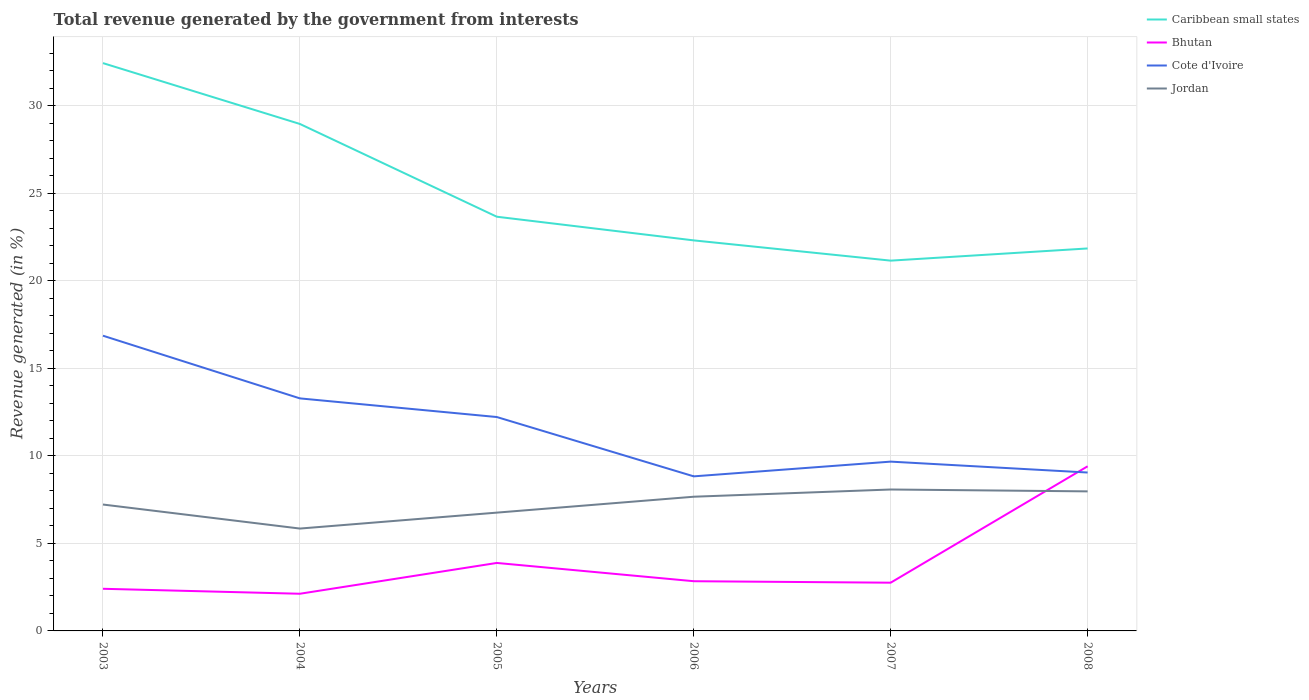Does the line corresponding to Cote d'Ivoire intersect with the line corresponding to Jordan?
Your answer should be very brief. No. Is the number of lines equal to the number of legend labels?
Your answer should be compact. Yes. Across all years, what is the maximum total revenue generated in Cote d'Ivoire?
Provide a short and direct response. 8.83. What is the total total revenue generated in Bhutan in the graph?
Your response must be concise. -0.72. What is the difference between the highest and the second highest total revenue generated in Bhutan?
Your answer should be very brief. 7.28. What is the difference between the highest and the lowest total revenue generated in Caribbean small states?
Give a very brief answer. 2. How many years are there in the graph?
Keep it short and to the point. 6. Does the graph contain grids?
Offer a very short reply. Yes. How are the legend labels stacked?
Provide a succinct answer. Vertical. What is the title of the graph?
Provide a short and direct response. Total revenue generated by the government from interests. What is the label or title of the X-axis?
Make the answer very short. Years. What is the label or title of the Y-axis?
Provide a succinct answer. Revenue generated (in %). What is the Revenue generated (in %) of Caribbean small states in 2003?
Provide a succinct answer. 32.44. What is the Revenue generated (in %) of Bhutan in 2003?
Ensure brevity in your answer.  2.41. What is the Revenue generated (in %) in Cote d'Ivoire in 2003?
Keep it short and to the point. 16.87. What is the Revenue generated (in %) of Jordan in 2003?
Provide a succinct answer. 7.22. What is the Revenue generated (in %) in Caribbean small states in 2004?
Provide a succinct answer. 28.97. What is the Revenue generated (in %) in Bhutan in 2004?
Offer a very short reply. 2.12. What is the Revenue generated (in %) of Cote d'Ivoire in 2004?
Make the answer very short. 13.29. What is the Revenue generated (in %) in Jordan in 2004?
Keep it short and to the point. 5.85. What is the Revenue generated (in %) in Caribbean small states in 2005?
Provide a short and direct response. 23.67. What is the Revenue generated (in %) of Bhutan in 2005?
Offer a terse response. 3.88. What is the Revenue generated (in %) of Cote d'Ivoire in 2005?
Make the answer very short. 12.22. What is the Revenue generated (in %) of Jordan in 2005?
Offer a terse response. 6.76. What is the Revenue generated (in %) of Caribbean small states in 2006?
Keep it short and to the point. 22.31. What is the Revenue generated (in %) in Bhutan in 2006?
Provide a succinct answer. 2.84. What is the Revenue generated (in %) in Cote d'Ivoire in 2006?
Offer a terse response. 8.83. What is the Revenue generated (in %) in Jordan in 2006?
Give a very brief answer. 7.67. What is the Revenue generated (in %) in Caribbean small states in 2007?
Your response must be concise. 21.16. What is the Revenue generated (in %) in Bhutan in 2007?
Your response must be concise. 2.76. What is the Revenue generated (in %) in Cote d'Ivoire in 2007?
Your answer should be compact. 9.67. What is the Revenue generated (in %) of Jordan in 2007?
Ensure brevity in your answer.  8.08. What is the Revenue generated (in %) of Caribbean small states in 2008?
Offer a very short reply. 21.85. What is the Revenue generated (in %) of Bhutan in 2008?
Your response must be concise. 9.41. What is the Revenue generated (in %) in Cote d'Ivoire in 2008?
Your answer should be compact. 9.05. What is the Revenue generated (in %) in Jordan in 2008?
Provide a succinct answer. 7.97. Across all years, what is the maximum Revenue generated (in %) in Caribbean small states?
Your response must be concise. 32.44. Across all years, what is the maximum Revenue generated (in %) in Bhutan?
Offer a terse response. 9.41. Across all years, what is the maximum Revenue generated (in %) of Cote d'Ivoire?
Offer a very short reply. 16.87. Across all years, what is the maximum Revenue generated (in %) of Jordan?
Keep it short and to the point. 8.08. Across all years, what is the minimum Revenue generated (in %) of Caribbean small states?
Ensure brevity in your answer.  21.16. Across all years, what is the minimum Revenue generated (in %) in Bhutan?
Offer a very short reply. 2.12. Across all years, what is the minimum Revenue generated (in %) in Cote d'Ivoire?
Give a very brief answer. 8.83. Across all years, what is the minimum Revenue generated (in %) in Jordan?
Your answer should be compact. 5.85. What is the total Revenue generated (in %) in Caribbean small states in the graph?
Your answer should be very brief. 150.4. What is the total Revenue generated (in %) of Bhutan in the graph?
Your answer should be compact. 23.42. What is the total Revenue generated (in %) of Cote d'Ivoire in the graph?
Offer a very short reply. 69.93. What is the total Revenue generated (in %) of Jordan in the graph?
Offer a very short reply. 43.55. What is the difference between the Revenue generated (in %) of Caribbean small states in 2003 and that in 2004?
Provide a succinct answer. 3.48. What is the difference between the Revenue generated (in %) of Bhutan in 2003 and that in 2004?
Give a very brief answer. 0.28. What is the difference between the Revenue generated (in %) of Cote d'Ivoire in 2003 and that in 2004?
Your answer should be very brief. 3.58. What is the difference between the Revenue generated (in %) of Jordan in 2003 and that in 2004?
Ensure brevity in your answer.  1.37. What is the difference between the Revenue generated (in %) of Caribbean small states in 2003 and that in 2005?
Your answer should be very brief. 8.78. What is the difference between the Revenue generated (in %) in Bhutan in 2003 and that in 2005?
Offer a terse response. -1.48. What is the difference between the Revenue generated (in %) in Cote d'Ivoire in 2003 and that in 2005?
Offer a very short reply. 4.65. What is the difference between the Revenue generated (in %) in Jordan in 2003 and that in 2005?
Make the answer very short. 0.46. What is the difference between the Revenue generated (in %) in Caribbean small states in 2003 and that in 2006?
Keep it short and to the point. 10.13. What is the difference between the Revenue generated (in %) of Bhutan in 2003 and that in 2006?
Your response must be concise. -0.43. What is the difference between the Revenue generated (in %) in Cote d'Ivoire in 2003 and that in 2006?
Make the answer very short. 8.04. What is the difference between the Revenue generated (in %) in Jordan in 2003 and that in 2006?
Make the answer very short. -0.45. What is the difference between the Revenue generated (in %) of Caribbean small states in 2003 and that in 2007?
Ensure brevity in your answer.  11.29. What is the difference between the Revenue generated (in %) of Bhutan in 2003 and that in 2007?
Keep it short and to the point. -0.35. What is the difference between the Revenue generated (in %) in Cote d'Ivoire in 2003 and that in 2007?
Offer a very short reply. 7.19. What is the difference between the Revenue generated (in %) of Jordan in 2003 and that in 2007?
Your answer should be very brief. -0.86. What is the difference between the Revenue generated (in %) of Caribbean small states in 2003 and that in 2008?
Make the answer very short. 10.59. What is the difference between the Revenue generated (in %) of Bhutan in 2003 and that in 2008?
Your answer should be compact. -7. What is the difference between the Revenue generated (in %) in Cote d'Ivoire in 2003 and that in 2008?
Give a very brief answer. 7.82. What is the difference between the Revenue generated (in %) of Jordan in 2003 and that in 2008?
Make the answer very short. -0.75. What is the difference between the Revenue generated (in %) of Caribbean small states in 2004 and that in 2005?
Ensure brevity in your answer.  5.3. What is the difference between the Revenue generated (in %) of Bhutan in 2004 and that in 2005?
Your answer should be compact. -1.76. What is the difference between the Revenue generated (in %) of Cote d'Ivoire in 2004 and that in 2005?
Your answer should be very brief. 1.07. What is the difference between the Revenue generated (in %) in Jordan in 2004 and that in 2005?
Your response must be concise. -0.91. What is the difference between the Revenue generated (in %) in Caribbean small states in 2004 and that in 2006?
Offer a terse response. 6.65. What is the difference between the Revenue generated (in %) of Bhutan in 2004 and that in 2006?
Offer a terse response. -0.72. What is the difference between the Revenue generated (in %) of Cote d'Ivoire in 2004 and that in 2006?
Ensure brevity in your answer.  4.45. What is the difference between the Revenue generated (in %) in Jordan in 2004 and that in 2006?
Offer a very short reply. -1.82. What is the difference between the Revenue generated (in %) in Caribbean small states in 2004 and that in 2007?
Your answer should be very brief. 7.81. What is the difference between the Revenue generated (in %) of Bhutan in 2004 and that in 2007?
Your answer should be compact. -0.63. What is the difference between the Revenue generated (in %) of Cote d'Ivoire in 2004 and that in 2007?
Provide a short and direct response. 3.61. What is the difference between the Revenue generated (in %) of Jordan in 2004 and that in 2007?
Provide a succinct answer. -2.23. What is the difference between the Revenue generated (in %) in Caribbean small states in 2004 and that in 2008?
Give a very brief answer. 7.11. What is the difference between the Revenue generated (in %) of Bhutan in 2004 and that in 2008?
Your response must be concise. -7.28. What is the difference between the Revenue generated (in %) of Cote d'Ivoire in 2004 and that in 2008?
Ensure brevity in your answer.  4.24. What is the difference between the Revenue generated (in %) of Jordan in 2004 and that in 2008?
Give a very brief answer. -2.12. What is the difference between the Revenue generated (in %) in Caribbean small states in 2005 and that in 2006?
Provide a succinct answer. 1.35. What is the difference between the Revenue generated (in %) in Bhutan in 2005 and that in 2006?
Your answer should be very brief. 1.04. What is the difference between the Revenue generated (in %) of Cote d'Ivoire in 2005 and that in 2006?
Offer a very short reply. 3.39. What is the difference between the Revenue generated (in %) of Jordan in 2005 and that in 2006?
Make the answer very short. -0.91. What is the difference between the Revenue generated (in %) of Caribbean small states in 2005 and that in 2007?
Offer a very short reply. 2.51. What is the difference between the Revenue generated (in %) of Bhutan in 2005 and that in 2007?
Ensure brevity in your answer.  1.13. What is the difference between the Revenue generated (in %) in Cote d'Ivoire in 2005 and that in 2007?
Make the answer very short. 2.55. What is the difference between the Revenue generated (in %) of Jordan in 2005 and that in 2007?
Provide a short and direct response. -1.32. What is the difference between the Revenue generated (in %) of Caribbean small states in 2005 and that in 2008?
Ensure brevity in your answer.  1.81. What is the difference between the Revenue generated (in %) in Bhutan in 2005 and that in 2008?
Your answer should be compact. -5.52. What is the difference between the Revenue generated (in %) of Cote d'Ivoire in 2005 and that in 2008?
Provide a short and direct response. 3.17. What is the difference between the Revenue generated (in %) of Jordan in 2005 and that in 2008?
Give a very brief answer. -1.21. What is the difference between the Revenue generated (in %) of Caribbean small states in 2006 and that in 2007?
Offer a very short reply. 1.16. What is the difference between the Revenue generated (in %) in Bhutan in 2006 and that in 2007?
Your answer should be very brief. 0.08. What is the difference between the Revenue generated (in %) in Cote d'Ivoire in 2006 and that in 2007?
Offer a very short reply. -0.84. What is the difference between the Revenue generated (in %) of Jordan in 2006 and that in 2007?
Ensure brevity in your answer.  -0.41. What is the difference between the Revenue generated (in %) of Caribbean small states in 2006 and that in 2008?
Your answer should be compact. 0.46. What is the difference between the Revenue generated (in %) in Bhutan in 2006 and that in 2008?
Offer a very short reply. -6.57. What is the difference between the Revenue generated (in %) of Cote d'Ivoire in 2006 and that in 2008?
Ensure brevity in your answer.  -0.22. What is the difference between the Revenue generated (in %) of Jordan in 2006 and that in 2008?
Your answer should be compact. -0.31. What is the difference between the Revenue generated (in %) in Caribbean small states in 2007 and that in 2008?
Ensure brevity in your answer.  -0.7. What is the difference between the Revenue generated (in %) in Bhutan in 2007 and that in 2008?
Provide a short and direct response. -6.65. What is the difference between the Revenue generated (in %) in Cote d'Ivoire in 2007 and that in 2008?
Your response must be concise. 0.62. What is the difference between the Revenue generated (in %) in Jordan in 2007 and that in 2008?
Give a very brief answer. 0.11. What is the difference between the Revenue generated (in %) of Caribbean small states in 2003 and the Revenue generated (in %) of Bhutan in 2004?
Your answer should be very brief. 30.32. What is the difference between the Revenue generated (in %) in Caribbean small states in 2003 and the Revenue generated (in %) in Cote d'Ivoire in 2004?
Your answer should be compact. 19.16. What is the difference between the Revenue generated (in %) of Caribbean small states in 2003 and the Revenue generated (in %) of Jordan in 2004?
Your answer should be very brief. 26.59. What is the difference between the Revenue generated (in %) of Bhutan in 2003 and the Revenue generated (in %) of Cote d'Ivoire in 2004?
Your response must be concise. -10.88. What is the difference between the Revenue generated (in %) of Bhutan in 2003 and the Revenue generated (in %) of Jordan in 2004?
Provide a short and direct response. -3.44. What is the difference between the Revenue generated (in %) in Cote d'Ivoire in 2003 and the Revenue generated (in %) in Jordan in 2004?
Your answer should be compact. 11.02. What is the difference between the Revenue generated (in %) of Caribbean small states in 2003 and the Revenue generated (in %) of Bhutan in 2005?
Your response must be concise. 28.56. What is the difference between the Revenue generated (in %) of Caribbean small states in 2003 and the Revenue generated (in %) of Cote d'Ivoire in 2005?
Make the answer very short. 20.22. What is the difference between the Revenue generated (in %) in Caribbean small states in 2003 and the Revenue generated (in %) in Jordan in 2005?
Give a very brief answer. 25.68. What is the difference between the Revenue generated (in %) of Bhutan in 2003 and the Revenue generated (in %) of Cote d'Ivoire in 2005?
Your response must be concise. -9.81. What is the difference between the Revenue generated (in %) in Bhutan in 2003 and the Revenue generated (in %) in Jordan in 2005?
Make the answer very short. -4.35. What is the difference between the Revenue generated (in %) of Cote d'Ivoire in 2003 and the Revenue generated (in %) of Jordan in 2005?
Ensure brevity in your answer.  10.11. What is the difference between the Revenue generated (in %) of Caribbean small states in 2003 and the Revenue generated (in %) of Bhutan in 2006?
Give a very brief answer. 29.6. What is the difference between the Revenue generated (in %) in Caribbean small states in 2003 and the Revenue generated (in %) in Cote d'Ivoire in 2006?
Keep it short and to the point. 23.61. What is the difference between the Revenue generated (in %) of Caribbean small states in 2003 and the Revenue generated (in %) of Jordan in 2006?
Your answer should be very brief. 24.77. What is the difference between the Revenue generated (in %) of Bhutan in 2003 and the Revenue generated (in %) of Cote d'Ivoire in 2006?
Offer a terse response. -6.42. What is the difference between the Revenue generated (in %) of Bhutan in 2003 and the Revenue generated (in %) of Jordan in 2006?
Offer a terse response. -5.26. What is the difference between the Revenue generated (in %) in Cote d'Ivoire in 2003 and the Revenue generated (in %) in Jordan in 2006?
Make the answer very short. 9.2. What is the difference between the Revenue generated (in %) of Caribbean small states in 2003 and the Revenue generated (in %) of Bhutan in 2007?
Your answer should be very brief. 29.69. What is the difference between the Revenue generated (in %) in Caribbean small states in 2003 and the Revenue generated (in %) in Cote d'Ivoire in 2007?
Provide a short and direct response. 22.77. What is the difference between the Revenue generated (in %) in Caribbean small states in 2003 and the Revenue generated (in %) in Jordan in 2007?
Ensure brevity in your answer.  24.36. What is the difference between the Revenue generated (in %) of Bhutan in 2003 and the Revenue generated (in %) of Cote d'Ivoire in 2007?
Make the answer very short. -7.27. What is the difference between the Revenue generated (in %) in Bhutan in 2003 and the Revenue generated (in %) in Jordan in 2007?
Keep it short and to the point. -5.67. What is the difference between the Revenue generated (in %) in Cote d'Ivoire in 2003 and the Revenue generated (in %) in Jordan in 2007?
Provide a succinct answer. 8.79. What is the difference between the Revenue generated (in %) in Caribbean small states in 2003 and the Revenue generated (in %) in Bhutan in 2008?
Make the answer very short. 23.04. What is the difference between the Revenue generated (in %) of Caribbean small states in 2003 and the Revenue generated (in %) of Cote d'Ivoire in 2008?
Provide a short and direct response. 23.39. What is the difference between the Revenue generated (in %) in Caribbean small states in 2003 and the Revenue generated (in %) in Jordan in 2008?
Keep it short and to the point. 24.47. What is the difference between the Revenue generated (in %) in Bhutan in 2003 and the Revenue generated (in %) in Cote d'Ivoire in 2008?
Keep it short and to the point. -6.64. What is the difference between the Revenue generated (in %) in Bhutan in 2003 and the Revenue generated (in %) in Jordan in 2008?
Make the answer very short. -5.57. What is the difference between the Revenue generated (in %) of Cote d'Ivoire in 2003 and the Revenue generated (in %) of Jordan in 2008?
Provide a succinct answer. 8.89. What is the difference between the Revenue generated (in %) in Caribbean small states in 2004 and the Revenue generated (in %) in Bhutan in 2005?
Your answer should be compact. 25.08. What is the difference between the Revenue generated (in %) in Caribbean small states in 2004 and the Revenue generated (in %) in Cote d'Ivoire in 2005?
Provide a short and direct response. 16.75. What is the difference between the Revenue generated (in %) of Caribbean small states in 2004 and the Revenue generated (in %) of Jordan in 2005?
Provide a succinct answer. 22.21. What is the difference between the Revenue generated (in %) in Bhutan in 2004 and the Revenue generated (in %) in Cote d'Ivoire in 2005?
Offer a very short reply. -10.1. What is the difference between the Revenue generated (in %) in Bhutan in 2004 and the Revenue generated (in %) in Jordan in 2005?
Keep it short and to the point. -4.64. What is the difference between the Revenue generated (in %) of Cote d'Ivoire in 2004 and the Revenue generated (in %) of Jordan in 2005?
Offer a terse response. 6.53. What is the difference between the Revenue generated (in %) in Caribbean small states in 2004 and the Revenue generated (in %) in Bhutan in 2006?
Provide a succinct answer. 26.13. What is the difference between the Revenue generated (in %) in Caribbean small states in 2004 and the Revenue generated (in %) in Cote d'Ivoire in 2006?
Ensure brevity in your answer.  20.13. What is the difference between the Revenue generated (in %) of Caribbean small states in 2004 and the Revenue generated (in %) of Jordan in 2006?
Your answer should be compact. 21.3. What is the difference between the Revenue generated (in %) of Bhutan in 2004 and the Revenue generated (in %) of Cote d'Ivoire in 2006?
Ensure brevity in your answer.  -6.71. What is the difference between the Revenue generated (in %) of Bhutan in 2004 and the Revenue generated (in %) of Jordan in 2006?
Provide a short and direct response. -5.54. What is the difference between the Revenue generated (in %) in Cote d'Ivoire in 2004 and the Revenue generated (in %) in Jordan in 2006?
Your answer should be very brief. 5.62. What is the difference between the Revenue generated (in %) in Caribbean small states in 2004 and the Revenue generated (in %) in Bhutan in 2007?
Ensure brevity in your answer.  26.21. What is the difference between the Revenue generated (in %) in Caribbean small states in 2004 and the Revenue generated (in %) in Cote d'Ivoire in 2007?
Offer a very short reply. 19.29. What is the difference between the Revenue generated (in %) of Caribbean small states in 2004 and the Revenue generated (in %) of Jordan in 2007?
Offer a very short reply. 20.89. What is the difference between the Revenue generated (in %) of Bhutan in 2004 and the Revenue generated (in %) of Cote d'Ivoire in 2007?
Offer a terse response. -7.55. What is the difference between the Revenue generated (in %) in Bhutan in 2004 and the Revenue generated (in %) in Jordan in 2007?
Provide a short and direct response. -5.96. What is the difference between the Revenue generated (in %) in Cote d'Ivoire in 2004 and the Revenue generated (in %) in Jordan in 2007?
Your answer should be very brief. 5.21. What is the difference between the Revenue generated (in %) in Caribbean small states in 2004 and the Revenue generated (in %) in Bhutan in 2008?
Offer a very short reply. 19.56. What is the difference between the Revenue generated (in %) in Caribbean small states in 2004 and the Revenue generated (in %) in Cote d'Ivoire in 2008?
Offer a very short reply. 19.92. What is the difference between the Revenue generated (in %) of Caribbean small states in 2004 and the Revenue generated (in %) of Jordan in 2008?
Your answer should be very brief. 20.99. What is the difference between the Revenue generated (in %) of Bhutan in 2004 and the Revenue generated (in %) of Cote d'Ivoire in 2008?
Keep it short and to the point. -6.93. What is the difference between the Revenue generated (in %) of Bhutan in 2004 and the Revenue generated (in %) of Jordan in 2008?
Your answer should be very brief. -5.85. What is the difference between the Revenue generated (in %) in Cote d'Ivoire in 2004 and the Revenue generated (in %) in Jordan in 2008?
Your answer should be very brief. 5.31. What is the difference between the Revenue generated (in %) in Caribbean small states in 2005 and the Revenue generated (in %) in Bhutan in 2006?
Ensure brevity in your answer.  20.83. What is the difference between the Revenue generated (in %) of Caribbean small states in 2005 and the Revenue generated (in %) of Cote d'Ivoire in 2006?
Your answer should be very brief. 14.83. What is the difference between the Revenue generated (in %) of Caribbean small states in 2005 and the Revenue generated (in %) of Jordan in 2006?
Offer a very short reply. 16. What is the difference between the Revenue generated (in %) of Bhutan in 2005 and the Revenue generated (in %) of Cote d'Ivoire in 2006?
Offer a terse response. -4.95. What is the difference between the Revenue generated (in %) of Bhutan in 2005 and the Revenue generated (in %) of Jordan in 2006?
Ensure brevity in your answer.  -3.78. What is the difference between the Revenue generated (in %) in Cote d'Ivoire in 2005 and the Revenue generated (in %) in Jordan in 2006?
Provide a short and direct response. 4.55. What is the difference between the Revenue generated (in %) of Caribbean small states in 2005 and the Revenue generated (in %) of Bhutan in 2007?
Make the answer very short. 20.91. What is the difference between the Revenue generated (in %) in Caribbean small states in 2005 and the Revenue generated (in %) in Cote d'Ivoire in 2007?
Your answer should be very brief. 13.99. What is the difference between the Revenue generated (in %) in Caribbean small states in 2005 and the Revenue generated (in %) in Jordan in 2007?
Provide a succinct answer. 15.59. What is the difference between the Revenue generated (in %) in Bhutan in 2005 and the Revenue generated (in %) in Cote d'Ivoire in 2007?
Your answer should be compact. -5.79. What is the difference between the Revenue generated (in %) in Bhutan in 2005 and the Revenue generated (in %) in Jordan in 2007?
Make the answer very short. -4.2. What is the difference between the Revenue generated (in %) in Cote d'Ivoire in 2005 and the Revenue generated (in %) in Jordan in 2007?
Make the answer very short. 4.14. What is the difference between the Revenue generated (in %) in Caribbean small states in 2005 and the Revenue generated (in %) in Bhutan in 2008?
Make the answer very short. 14.26. What is the difference between the Revenue generated (in %) in Caribbean small states in 2005 and the Revenue generated (in %) in Cote d'Ivoire in 2008?
Offer a very short reply. 14.62. What is the difference between the Revenue generated (in %) in Caribbean small states in 2005 and the Revenue generated (in %) in Jordan in 2008?
Give a very brief answer. 15.69. What is the difference between the Revenue generated (in %) in Bhutan in 2005 and the Revenue generated (in %) in Cote d'Ivoire in 2008?
Give a very brief answer. -5.17. What is the difference between the Revenue generated (in %) of Bhutan in 2005 and the Revenue generated (in %) of Jordan in 2008?
Keep it short and to the point. -4.09. What is the difference between the Revenue generated (in %) of Cote d'Ivoire in 2005 and the Revenue generated (in %) of Jordan in 2008?
Offer a very short reply. 4.25. What is the difference between the Revenue generated (in %) of Caribbean small states in 2006 and the Revenue generated (in %) of Bhutan in 2007?
Offer a very short reply. 19.56. What is the difference between the Revenue generated (in %) in Caribbean small states in 2006 and the Revenue generated (in %) in Cote d'Ivoire in 2007?
Your answer should be very brief. 12.64. What is the difference between the Revenue generated (in %) of Caribbean small states in 2006 and the Revenue generated (in %) of Jordan in 2007?
Offer a terse response. 14.23. What is the difference between the Revenue generated (in %) of Bhutan in 2006 and the Revenue generated (in %) of Cote d'Ivoire in 2007?
Your answer should be very brief. -6.83. What is the difference between the Revenue generated (in %) of Bhutan in 2006 and the Revenue generated (in %) of Jordan in 2007?
Keep it short and to the point. -5.24. What is the difference between the Revenue generated (in %) in Cote d'Ivoire in 2006 and the Revenue generated (in %) in Jordan in 2007?
Your answer should be very brief. 0.75. What is the difference between the Revenue generated (in %) in Caribbean small states in 2006 and the Revenue generated (in %) in Bhutan in 2008?
Offer a terse response. 12.91. What is the difference between the Revenue generated (in %) in Caribbean small states in 2006 and the Revenue generated (in %) in Cote d'Ivoire in 2008?
Your response must be concise. 13.26. What is the difference between the Revenue generated (in %) in Caribbean small states in 2006 and the Revenue generated (in %) in Jordan in 2008?
Ensure brevity in your answer.  14.34. What is the difference between the Revenue generated (in %) in Bhutan in 2006 and the Revenue generated (in %) in Cote d'Ivoire in 2008?
Offer a terse response. -6.21. What is the difference between the Revenue generated (in %) in Bhutan in 2006 and the Revenue generated (in %) in Jordan in 2008?
Ensure brevity in your answer.  -5.13. What is the difference between the Revenue generated (in %) in Cote d'Ivoire in 2006 and the Revenue generated (in %) in Jordan in 2008?
Your answer should be very brief. 0.86. What is the difference between the Revenue generated (in %) of Caribbean small states in 2007 and the Revenue generated (in %) of Bhutan in 2008?
Your answer should be very brief. 11.75. What is the difference between the Revenue generated (in %) of Caribbean small states in 2007 and the Revenue generated (in %) of Cote d'Ivoire in 2008?
Keep it short and to the point. 12.11. What is the difference between the Revenue generated (in %) of Caribbean small states in 2007 and the Revenue generated (in %) of Jordan in 2008?
Ensure brevity in your answer.  13.18. What is the difference between the Revenue generated (in %) in Bhutan in 2007 and the Revenue generated (in %) in Cote d'Ivoire in 2008?
Provide a short and direct response. -6.29. What is the difference between the Revenue generated (in %) of Bhutan in 2007 and the Revenue generated (in %) of Jordan in 2008?
Your answer should be very brief. -5.22. What is the difference between the Revenue generated (in %) in Cote d'Ivoire in 2007 and the Revenue generated (in %) in Jordan in 2008?
Give a very brief answer. 1.7. What is the average Revenue generated (in %) in Caribbean small states per year?
Keep it short and to the point. 25.07. What is the average Revenue generated (in %) of Bhutan per year?
Give a very brief answer. 3.9. What is the average Revenue generated (in %) of Cote d'Ivoire per year?
Offer a very short reply. 11.65. What is the average Revenue generated (in %) of Jordan per year?
Offer a terse response. 7.26. In the year 2003, what is the difference between the Revenue generated (in %) in Caribbean small states and Revenue generated (in %) in Bhutan?
Make the answer very short. 30.03. In the year 2003, what is the difference between the Revenue generated (in %) in Caribbean small states and Revenue generated (in %) in Cote d'Ivoire?
Your answer should be compact. 15.57. In the year 2003, what is the difference between the Revenue generated (in %) of Caribbean small states and Revenue generated (in %) of Jordan?
Offer a very short reply. 25.22. In the year 2003, what is the difference between the Revenue generated (in %) in Bhutan and Revenue generated (in %) in Cote d'Ivoire?
Offer a very short reply. -14.46. In the year 2003, what is the difference between the Revenue generated (in %) of Bhutan and Revenue generated (in %) of Jordan?
Ensure brevity in your answer.  -4.81. In the year 2003, what is the difference between the Revenue generated (in %) of Cote d'Ivoire and Revenue generated (in %) of Jordan?
Your answer should be very brief. 9.65. In the year 2004, what is the difference between the Revenue generated (in %) in Caribbean small states and Revenue generated (in %) in Bhutan?
Keep it short and to the point. 26.84. In the year 2004, what is the difference between the Revenue generated (in %) in Caribbean small states and Revenue generated (in %) in Cote d'Ivoire?
Make the answer very short. 15.68. In the year 2004, what is the difference between the Revenue generated (in %) in Caribbean small states and Revenue generated (in %) in Jordan?
Make the answer very short. 23.12. In the year 2004, what is the difference between the Revenue generated (in %) of Bhutan and Revenue generated (in %) of Cote d'Ivoire?
Provide a succinct answer. -11.16. In the year 2004, what is the difference between the Revenue generated (in %) in Bhutan and Revenue generated (in %) in Jordan?
Ensure brevity in your answer.  -3.72. In the year 2004, what is the difference between the Revenue generated (in %) of Cote d'Ivoire and Revenue generated (in %) of Jordan?
Your answer should be compact. 7.44. In the year 2005, what is the difference between the Revenue generated (in %) of Caribbean small states and Revenue generated (in %) of Bhutan?
Ensure brevity in your answer.  19.78. In the year 2005, what is the difference between the Revenue generated (in %) in Caribbean small states and Revenue generated (in %) in Cote d'Ivoire?
Ensure brevity in your answer.  11.44. In the year 2005, what is the difference between the Revenue generated (in %) in Caribbean small states and Revenue generated (in %) in Jordan?
Offer a very short reply. 16.91. In the year 2005, what is the difference between the Revenue generated (in %) of Bhutan and Revenue generated (in %) of Cote d'Ivoire?
Ensure brevity in your answer.  -8.34. In the year 2005, what is the difference between the Revenue generated (in %) in Bhutan and Revenue generated (in %) in Jordan?
Your response must be concise. -2.88. In the year 2005, what is the difference between the Revenue generated (in %) of Cote d'Ivoire and Revenue generated (in %) of Jordan?
Provide a short and direct response. 5.46. In the year 2006, what is the difference between the Revenue generated (in %) in Caribbean small states and Revenue generated (in %) in Bhutan?
Give a very brief answer. 19.47. In the year 2006, what is the difference between the Revenue generated (in %) of Caribbean small states and Revenue generated (in %) of Cote d'Ivoire?
Your answer should be compact. 13.48. In the year 2006, what is the difference between the Revenue generated (in %) in Caribbean small states and Revenue generated (in %) in Jordan?
Make the answer very short. 14.65. In the year 2006, what is the difference between the Revenue generated (in %) of Bhutan and Revenue generated (in %) of Cote d'Ivoire?
Your answer should be compact. -5.99. In the year 2006, what is the difference between the Revenue generated (in %) in Bhutan and Revenue generated (in %) in Jordan?
Make the answer very short. -4.83. In the year 2006, what is the difference between the Revenue generated (in %) in Cote d'Ivoire and Revenue generated (in %) in Jordan?
Your answer should be compact. 1.16. In the year 2007, what is the difference between the Revenue generated (in %) of Caribbean small states and Revenue generated (in %) of Bhutan?
Your response must be concise. 18.4. In the year 2007, what is the difference between the Revenue generated (in %) of Caribbean small states and Revenue generated (in %) of Cote d'Ivoire?
Your answer should be very brief. 11.48. In the year 2007, what is the difference between the Revenue generated (in %) in Caribbean small states and Revenue generated (in %) in Jordan?
Your answer should be very brief. 13.08. In the year 2007, what is the difference between the Revenue generated (in %) of Bhutan and Revenue generated (in %) of Cote d'Ivoire?
Offer a very short reply. -6.92. In the year 2007, what is the difference between the Revenue generated (in %) of Bhutan and Revenue generated (in %) of Jordan?
Your answer should be very brief. -5.32. In the year 2007, what is the difference between the Revenue generated (in %) of Cote d'Ivoire and Revenue generated (in %) of Jordan?
Offer a very short reply. 1.59. In the year 2008, what is the difference between the Revenue generated (in %) of Caribbean small states and Revenue generated (in %) of Bhutan?
Ensure brevity in your answer.  12.45. In the year 2008, what is the difference between the Revenue generated (in %) in Caribbean small states and Revenue generated (in %) in Cote d'Ivoire?
Your answer should be compact. 12.8. In the year 2008, what is the difference between the Revenue generated (in %) in Caribbean small states and Revenue generated (in %) in Jordan?
Your answer should be very brief. 13.88. In the year 2008, what is the difference between the Revenue generated (in %) of Bhutan and Revenue generated (in %) of Cote d'Ivoire?
Make the answer very short. 0.36. In the year 2008, what is the difference between the Revenue generated (in %) in Bhutan and Revenue generated (in %) in Jordan?
Your answer should be very brief. 1.43. In the year 2008, what is the difference between the Revenue generated (in %) in Cote d'Ivoire and Revenue generated (in %) in Jordan?
Make the answer very short. 1.08. What is the ratio of the Revenue generated (in %) in Caribbean small states in 2003 to that in 2004?
Provide a succinct answer. 1.12. What is the ratio of the Revenue generated (in %) in Bhutan in 2003 to that in 2004?
Ensure brevity in your answer.  1.13. What is the ratio of the Revenue generated (in %) of Cote d'Ivoire in 2003 to that in 2004?
Provide a short and direct response. 1.27. What is the ratio of the Revenue generated (in %) of Jordan in 2003 to that in 2004?
Provide a short and direct response. 1.23. What is the ratio of the Revenue generated (in %) of Caribbean small states in 2003 to that in 2005?
Keep it short and to the point. 1.37. What is the ratio of the Revenue generated (in %) in Bhutan in 2003 to that in 2005?
Make the answer very short. 0.62. What is the ratio of the Revenue generated (in %) in Cote d'Ivoire in 2003 to that in 2005?
Your response must be concise. 1.38. What is the ratio of the Revenue generated (in %) in Jordan in 2003 to that in 2005?
Your answer should be very brief. 1.07. What is the ratio of the Revenue generated (in %) in Caribbean small states in 2003 to that in 2006?
Your answer should be very brief. 1.45. What is the ratio of the Revenue generated (in %) in Bhutan in 2003 to that in 2006?
Give a very brief answer. 0.85. What is the ratio of the Revenue generated (in %) in Cote d'Ivoire in 2003 to that in 2006?
Your response must be concise. 1.91. What is the ratio of the Revenue generated (in %) of Jordan in 2003 to that in 2006?
Give a very brief answer. 0.94. What is the ratio of the Revenue generated (in %) in Caribbean small states in 2003 to that in 2007?
Make the answer very short. 1.53. What is the ratio of the Revenue generated (in %) of Bhutan in 2003 to that in 2007?
Provide a short and direct response. 0.87. What is the ratio of the Revenue generated (in %) in Cote d'Ivoire in 2003 to that in 2007?
Make the answer very short. 1.74. What is the ratio of the Revenue generated (in %) in Jordan in 2003 to that in 2007?
Your response must be concise. 0.89. What is the ratio of the Revenue generated (in %) in Caribbean small states in 2003 to that in 2008?
Give a very brief answer. 1.48. What is the ratio of the Revenue generated (in %) of Bhutan in 2003 to that in 2008?
Keep it short and to the point. 0.26. What is the ratio of the Revenue generated (in %) of Cote d'Ivoire in 2003 to that in 2008?
Your answer should be very brief. 1.86. What is the ratio of the Revenue generated (in %) in Jordan in 2003 to that in 2008?
Offer a terse response. 0.91. What is the ratio of the Revenue generated (in %) of Caribbean small states in 2004 to that in 2005?
Provide a short and direct response. 1.22. What is the ratio of the Revenue generated (in %) in Bhutan in 2004 to that in 2005?
Offer a terse response. 0.55. What is the ratio of the Revenue generated (in %) of Cote d'Ivoire in 2004 to that in 2005?
Keep it short and to the point. 1.09. What is the ratio of the Revenue generated (in %) of Jordan in 2004 to that in 2005?
Your response must be concise. 0.87. What is the ratio of the Revenue generated (in %) of Caribbean small states in 2004 to that in 2006?
Keep it short and to the point. 1.3. What is the ratio of the Revenue generated (in %) in Bhutan in 2004 to that in 2006?
Make the answer very short. 0.75. What is the ratio of the Revenue generated (in %) of Cote d'Ivoire in 2004 to that in 2006?
Offer a very short reply. 1.5. What is the ratio of the Revenue generated (in %) in Jordan in 2004 to that in 2006?
Give a very brief answer. 0.76. What is the ratio of the Revenue generated (in %) in Caribbean small states in 2004 to that in 2007?
Keep it short and to the point. 1.37. What is the ratio of the Revenue generated (in %) of Bhutan in 2004 to that in 2007?
Ensure brevity in your answer.  0.77. What is the ratio of the Revenue generated (in %) of Cote d'Ivoire in 2004 to that in 2007?
Offer a terse response. 1.37. What is the ratio of the Revenue generated (in %) in Jordan in 2004 to that in 2007?
Give a very brief answer. 0.72. What is the ratio of the Revenue generated (in %) of Caribbean small states in 2004 to that in 2008?
Provide a short and direct response. 1.33. What is the ratio of the Revenue generated (in %) of Bhutan in 2004 to that in 2008?
Keep it short and to the point. 0.23. What is the ratio of the Revenue generated (in %) of Cote d'Ivoire in 2004 to that in 2008?
Provide a short and direct response. 1.47. What is the ratio of the Revenue generated (in %) of Jordan in 2004 to that in 2008?
Your answer should be compact. 0.73. What is the ratio of the Revenue generated (in %) of Caribbean small states in 2005 to that in 2006?
Make the answer very short. 1.06. What is the ratio of the Revenue generated (in %) in Bhutan in 2005 to that in 2006?
Provide a short and direct response. 1.37. What is the ratio of the Revenue generated (in %) in Cote d'Ivoire in 2005 to that in 2006?
Ensure brevity in your answer.  1.38. What is the ratio of the Revenue generated (in %) in Jordan in 2005 to that in 2006?
Your response must be concise. 0.88. What is the ratio of the Revenue generated (in %) of Caribbean small states in 2005 to that in 2007?
Offer a very short reply. 1.12. What is the ratio of the Revenue generated (in %) in Bhutan in 2005 to that in 2007?
Your response must be concise. 1.41. What is the ratio of the Revenue generated (in %) of Cote d'Ivoire in 2005 to that in 2007?
Ensure brevity in your answer.  1.26. What is the ratio of the Revenue generated (in %) of Jordan in 2005 to that in 2007?
Offer a very short reply. 0.84. What is the ratio of the Revenue generated (in %) in Caribbean small states in 2005 to that in 2008?
Make the answer very short. 1.08. What is the ratio of the Revenue generated (in %) in Bhutan in 2005 to that in 2008?
Give a very brief answer. 0.41. What is the ratio of the Revenue generated (in %) in Cote d'Ivoire in 2005 to that in 2008?
Provide a short and direct response. 1.35. What is the ratio of the Revenue generated (in %) in Jordan in 2005 to that in 2008?
Ensure brevity in your answer.  0.85. What is the ratio of the Revenue generated (in %) of Caribbean small states in 2006 to that in 2007?
Your answer should be compact. 1.05. What is the ratio of the Revenue generated (in %) in Bhutan in 2006 to that in 2007?
Offer a terse response. 1.03. What is the ratio of the Revenue generated (in %) in Cote d'Ivoire in 2006 to that in 2007?
Provide a short and direct response. 0.91. What is the ratio of the Revenue generated (in %) of Jordan in 2006 to that in 2007?
Keep it short and to the point. 0.95. What is the ratio of the Revenue generated (in %) in Caribbean small states in 2006 to that in 2008?
Offer a very short reply. 1.02. What is the ratio of the Revenue generated (in %) of Bhutan in 2006 to that in 2008?
Give a very brief answer. 0.3. What is the ratio of the Revenue generated (in %) of Cote d'Ivoire in 2006 to that in 2008?
Ensure brevity in your answer.  0.98. What is the ratio of the Revenue generated (in %) of Jordan in 2006 to that in 2008?
Offer a terse response. 0.96. What is the ratio of the Revenue generated (in %) of Caribbean small states in 2007 to that in 2008?
Keep it short and to the point. 0.97. What is the ratio of the Revenue generated (in %) of Bhutan in 2007 to that in 2008?
Your response must be concise. 0.29. What is the ratio of the Revenue generated (in %) of Cote d'Ivoire in 2007 to that in 2008?
Make the answer very short. 1.07. What is the ratio of the Revenue generated (in %) of Jordan in 2007 to that in 2008?
Ensure brevity in your answer.  1.01. What is the difference between the highest and the second highest Revenue generated (in %) in Caribbean small states?
Provide a succinct answer. 3.48. What is the difference between the highest and the second highest Revenue generated (in %) in Bhutan?
Provide a short and direct response. 5.52. What is the difference between the highest and the second highest Revenue generated (in %) in Cote d'Ivoire?
Your answer should be very brief. 3.58. What is the difference between the highest and the second highest Revenue generated (in %) of Jordan?
Provide a succinct answer. 0.11. What is the difference between the highest and the lowest Revenue generated (in %) of Caribbean small states?
Your answer should be very brief. 11.29. What is the difference between the highest and the lowest Revenue generated (in %) in Bhutan?
Make the answer very short. 7.28. What is the difference between the highest and the lowest Revenue generated (in %) of Cote d'Ivoire?
Your answer should be very brief. 8.04. What is the difference between the highest and the lowest Revenue generated (in %) of Jordan?
Ensure brevity in your answer.  2.23. 